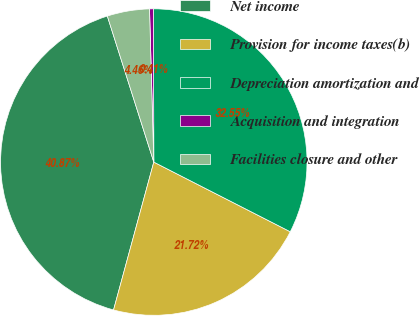<chart> <loc_0><loc_0><loc_500><loc_500><pie_chart><fcel>Net income<fcel>Provision for income taxes(b)<fcel>Depreciation amortization and<fcel>Acquisition and integration<fcel>Facilities closure and other<nl><fcel>40.87%<fcel>21.72%<fcel>32.55%<fcel>0.41%<fcel>4.46%<nl></chart> 